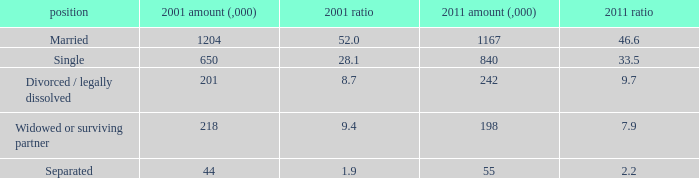What is the 2011 number (,000) when the status is separated? 55.0. 